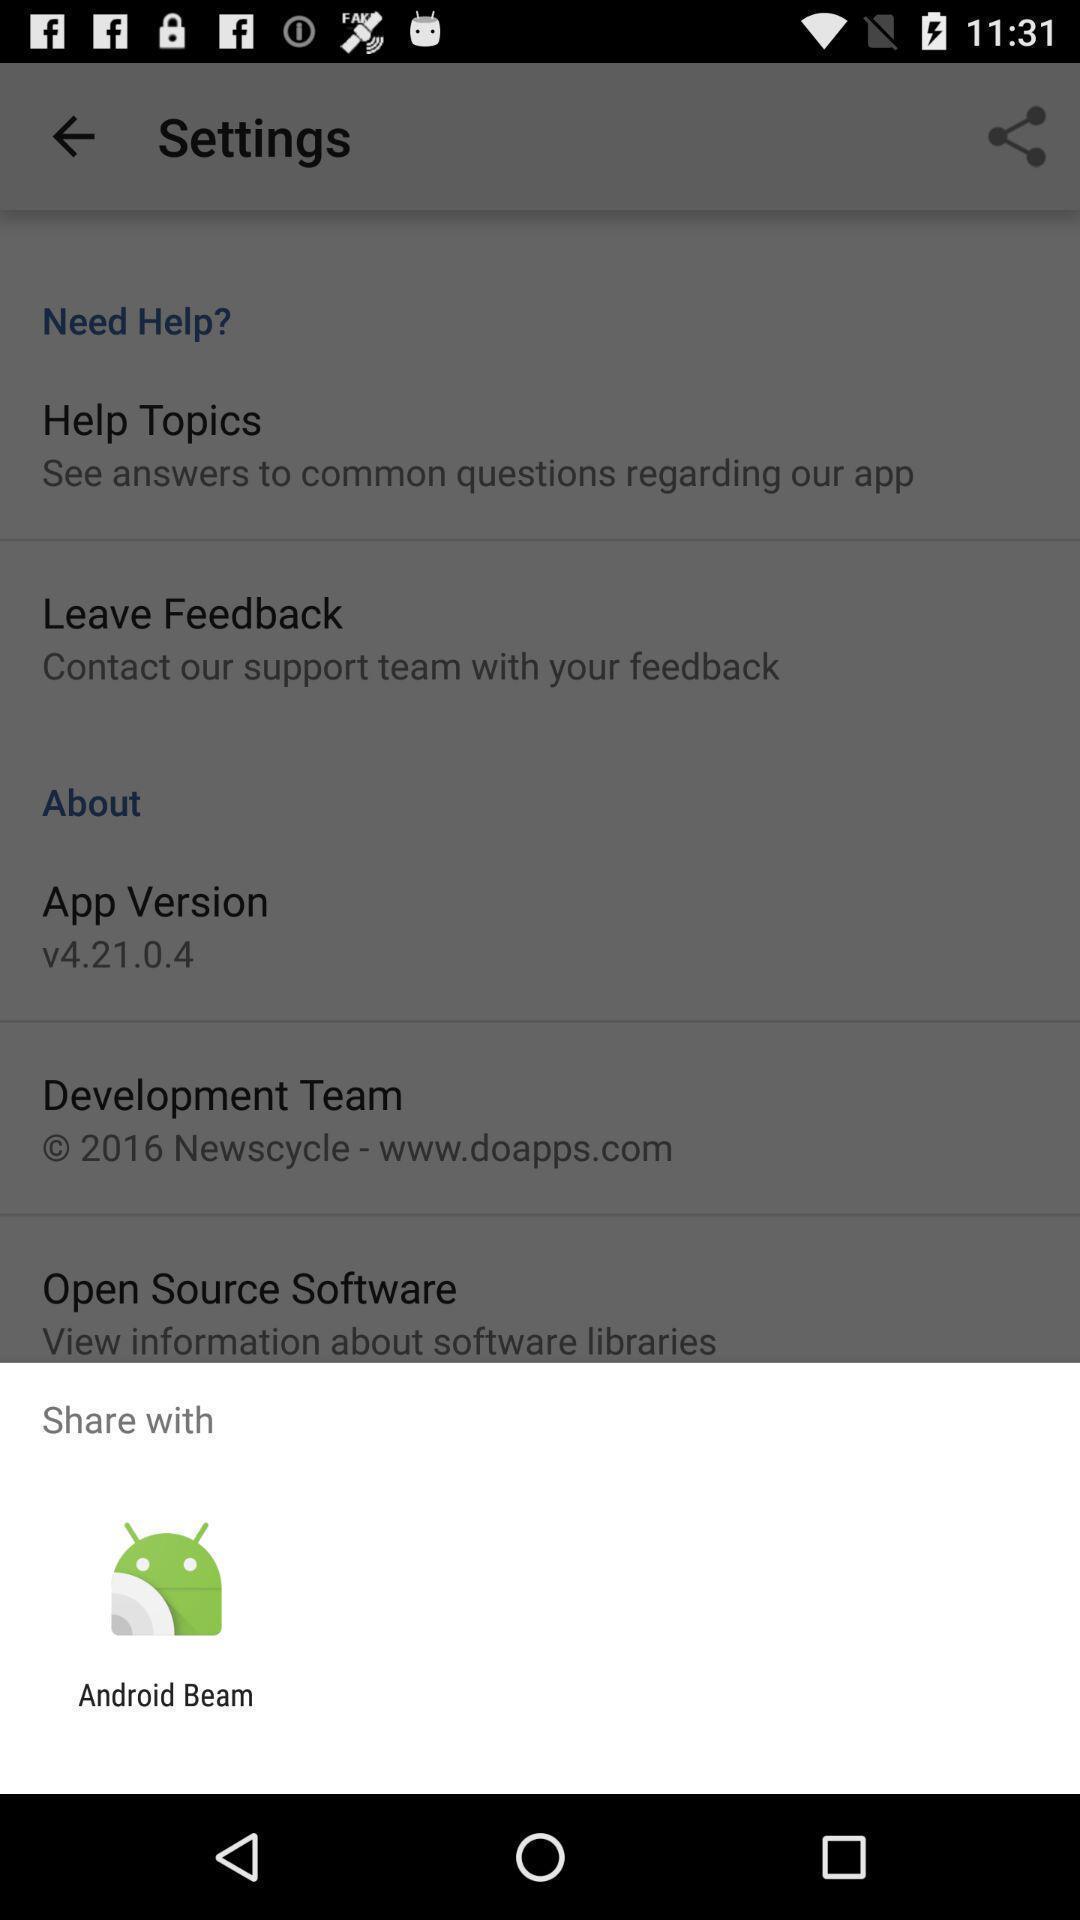Describe the visual elements of this screenshot. Pop-up displaying a app to share. 